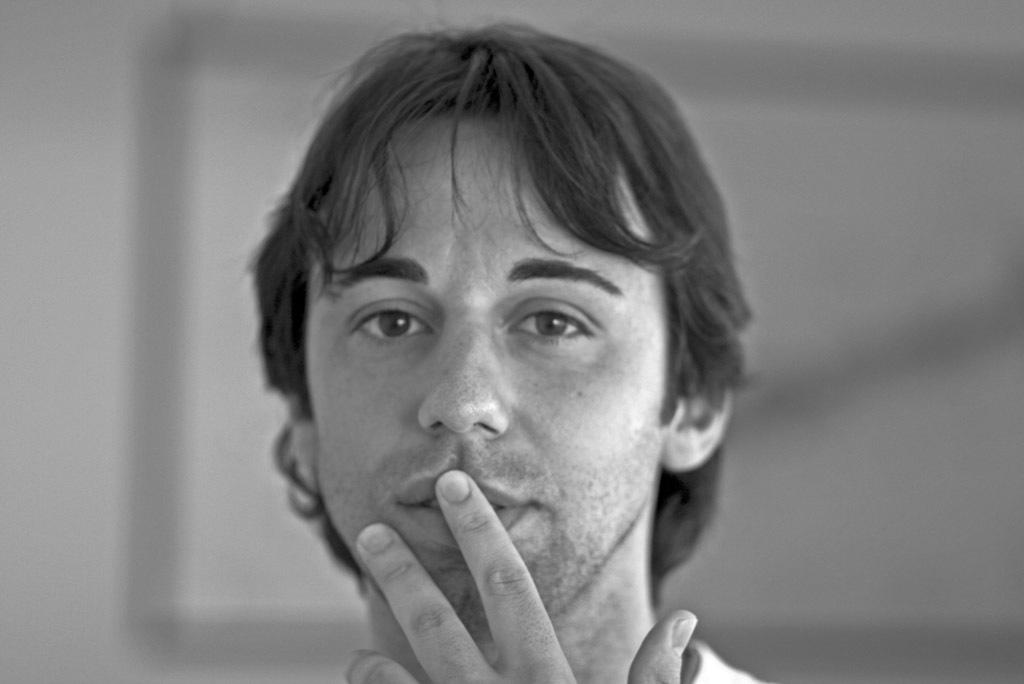What is the main subject of the image? There is a person in the image. Can you describe the background of the image? The background of the image is blurred. What type of tools is the carpenter using on the ship in the image? There is no carpenter or ship present in the image; it only features a person with a blurred background. How many bees can be seen buzzing around the person in the image? There are no bees present in the image. 